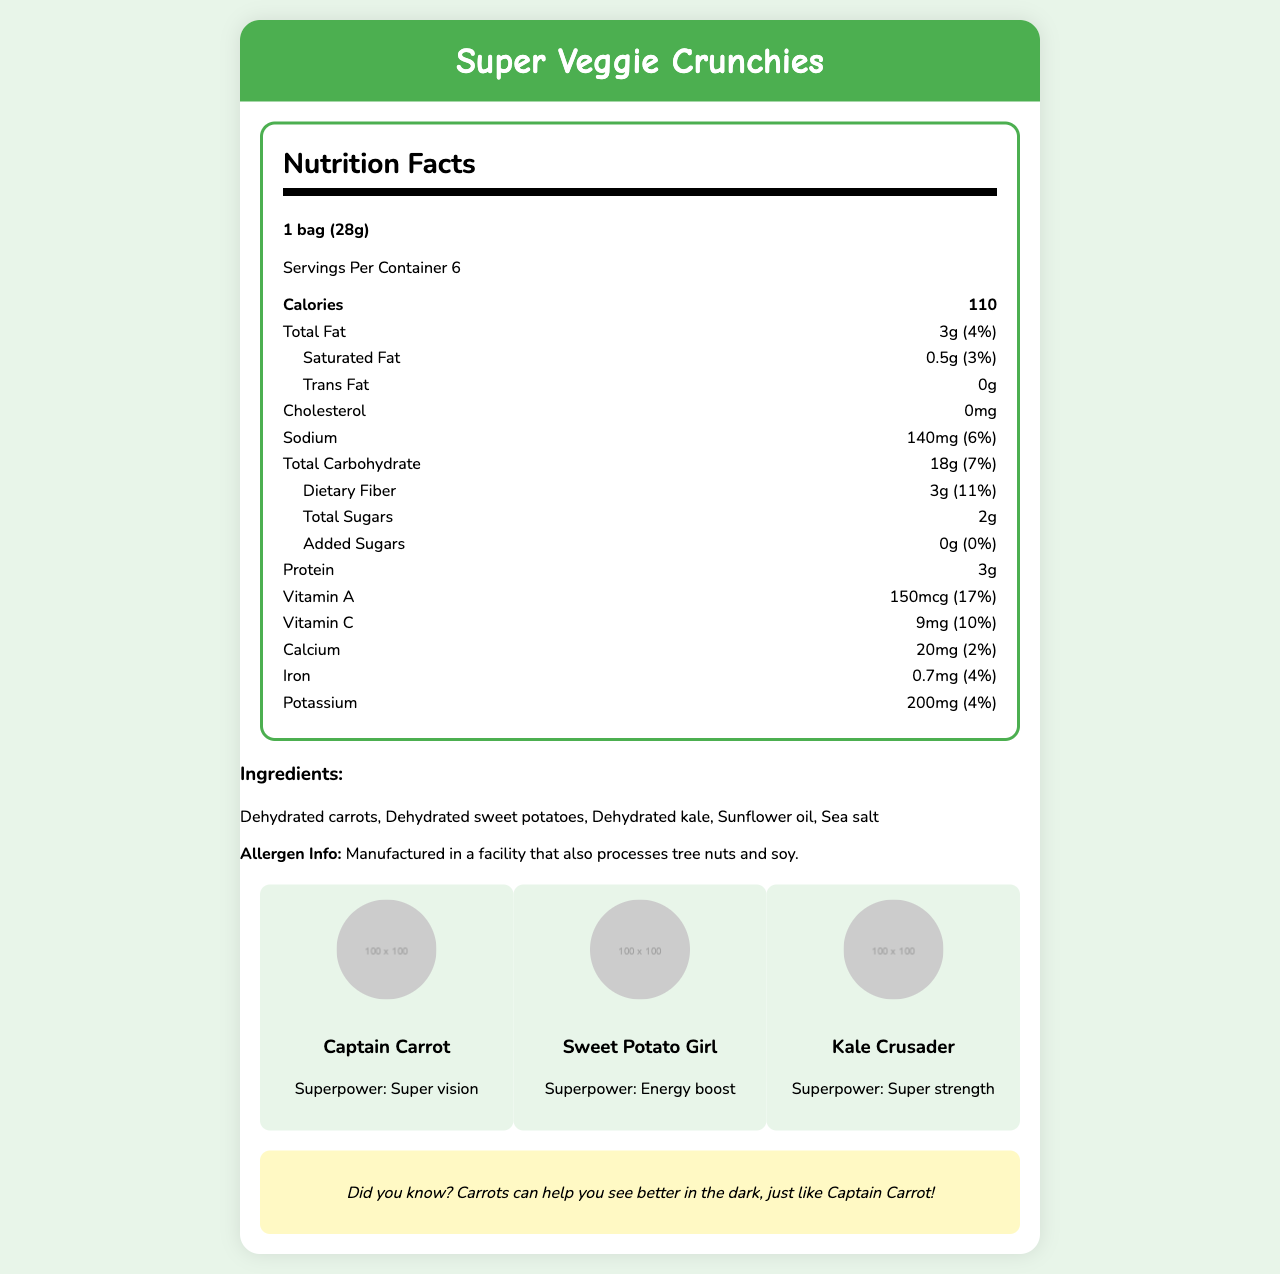who is Captain Carrot? The superhero information is listed in a dedicated section of the document.
Answer: Captain Carrot is a superhero with the superpower of super vision. how much sodium is in one serving? The nutrition label specifies the sodium content as 140mg per serving.
Answer: 140mg what ingredients are used in Super Veggie Crunchies? The ingredients are listed under the ingredients section.
Answer: Dehydrated carrots, Dehydrated sweet potatoes, Dehydrated kale, Sunflower oil, Sea salt how many calories are in one bag of Super Veggie Crunchies? The nutrition label specifies that there are 110 calories per serving, which is one bag.
Answer: 110 how much dietary fiber is in one serving? The nutrition label specifies that there are 3g of dietary fiber per serving.
Answer: 3g what is Sweet Potato Girl’s superpower? The superhero information section indicates Sweet Potato Girl's superpower as energy boost.
Answer: Energy boost how much Vitamin A is in one serving and what percentage of the daily value does it represent? The nutrition label lists 150mcg of Vitamin A, which represents 17% of the daily value.
Answer: 150mcg, 17% which of the following nutrients does not contain a specified amount in the nutrition label? A. Trans Fat B. Sodium C. Protein D. Vitamin C The nutrition label lists Trans Fat as 0g, while all other options have specified amounts.
Answer: A what is the total carbohydrate content in one bag? The nutrition label specifies that there are 18g of total carbohydrates per serving.
Answer: 18g does the product contain any added sugars? The nutrition label specifies that the product contains 0g of added sugars.
Answer: No what is the daily value percentage of calcium in one serving? The nutrition label specifies the calcium content as providing 2% of the daily value.
Answer: 2% does this product contain soy or tree nuts? The allergen information at the bottom specifies that it's manufactured in a facility that processes tree nuts and soy.
Answer: It is manufactured in a facility that processes tree nuts and soy, but the product's ingredients do not list them. which of the following is one of the veggie superheroes featured? A. Broccoli B. Captain Carrot C. Potato Pal D. Spinach Samurai The superhero section lists Captain Carrot as one of the superheroes.
Answer: B is this product high in protein? The nutrition label lists 3g of protein, which is not typically considered high.
Answer: No summarize the main idea of the document The document is a comprehensive nutrition facts label designed to inform consumers about the nutritional value and ingredients of the snack while incorporating fun elements like superhero characters and a fun fact.
Answer: The document provides nutritional information about Super Veggie Crunchies, a vegetable-based snack, including serving size, calorie content, and breakdown of nutrients. It lists the ingredients, potential allergens, and highlights three veggie superheroes with their superpowers. A fun fact about carrots is also included. where can I buy this product? The document does not provide information about where the product can be purchased.
Answer: Not enough information 